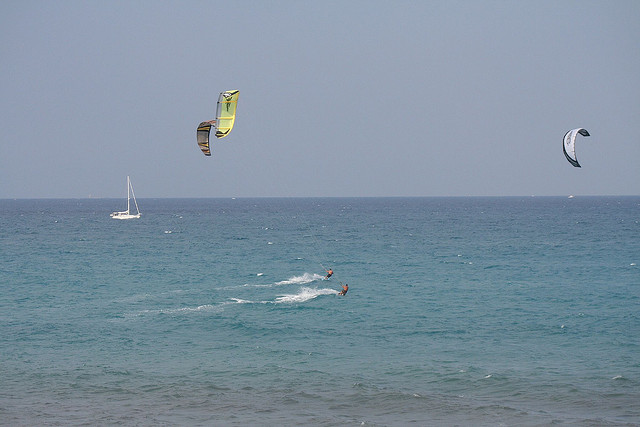What are the environmental conditions like in the image? The environmental conditions appear favorable for kite surfing. The sky is clear with minimal clouds, and the sea seems relatively calm with moderate waves, suggesting a consistent wind that is ideal for this activity. 